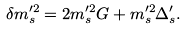Convert formula to latex. <formula><loc_0><loc_0><loc_500><loc_500>\delta m ^ { \prime 2 } _ { s } = 2 m _ { s } ^ { \prime 2 } G + m _ { s } ^ { \prime 2 } \Delta ^ { \prime } _ { s } .</formula> 